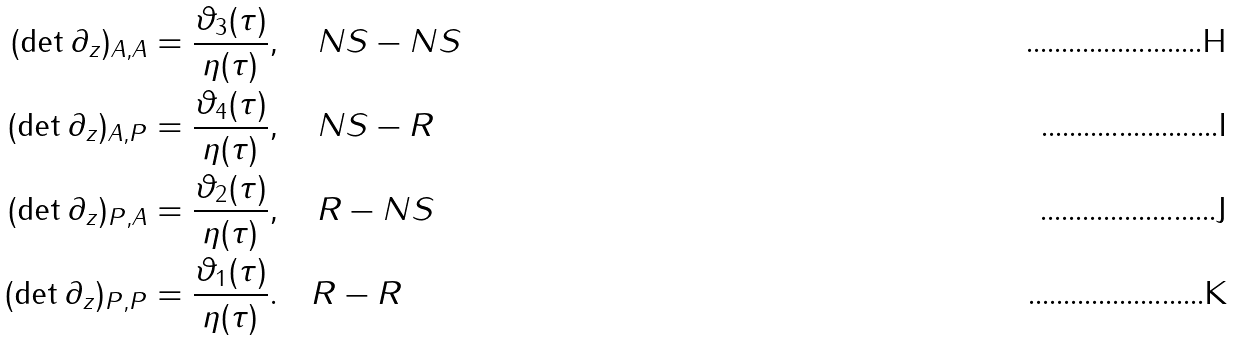<formula> <loc_0><loc_0><loc_500><loc_500>( \det \partial _ { z } ) _ { A , A } & = \frac { \vartheta _ { 3 } ( \tau ) } { \eta ( \tau ) } , \quad N S - N S \\ ( \det \partial _ { z } ) _ { A , P } & = \frac { \vartheta _ { 4 } ( \tau ) } { \eta ( \tau ) } , \quad N S - R \\ ( \det \partial _ { z } ) _ { P , A } & = \frac { \vartheta _ { 2 } ( \tau ) } { \eta ( \tau ) } , \quad R - N S \\ ( \det \partial _ { z } ) _ { P , P } & = \frac { \vartheta _ { 1 } ( \tau ) } { \eta ( \tau ) } . \quad R - R</formula> 